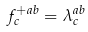Convert formula to latex. <formula><loc_0><loc_0><loc_500><loc_500>f _ { c } ^ { + a b } = \lambda _ { c } ^ { a b }</formula> 